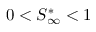Convert formula to latex. <formula><loc_0><loc_0><loc_500><loc_500>0 < S _ { \infty } ^ { * } < 1</formula> 